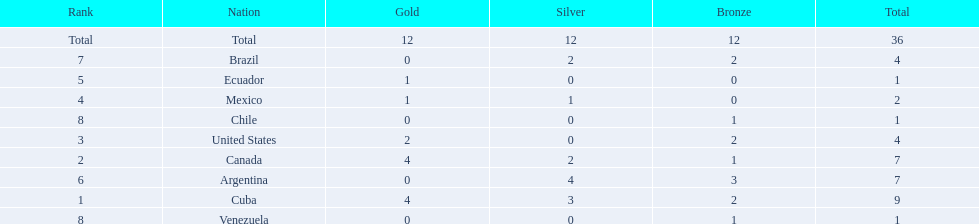How many total medals were there all together? 36. 